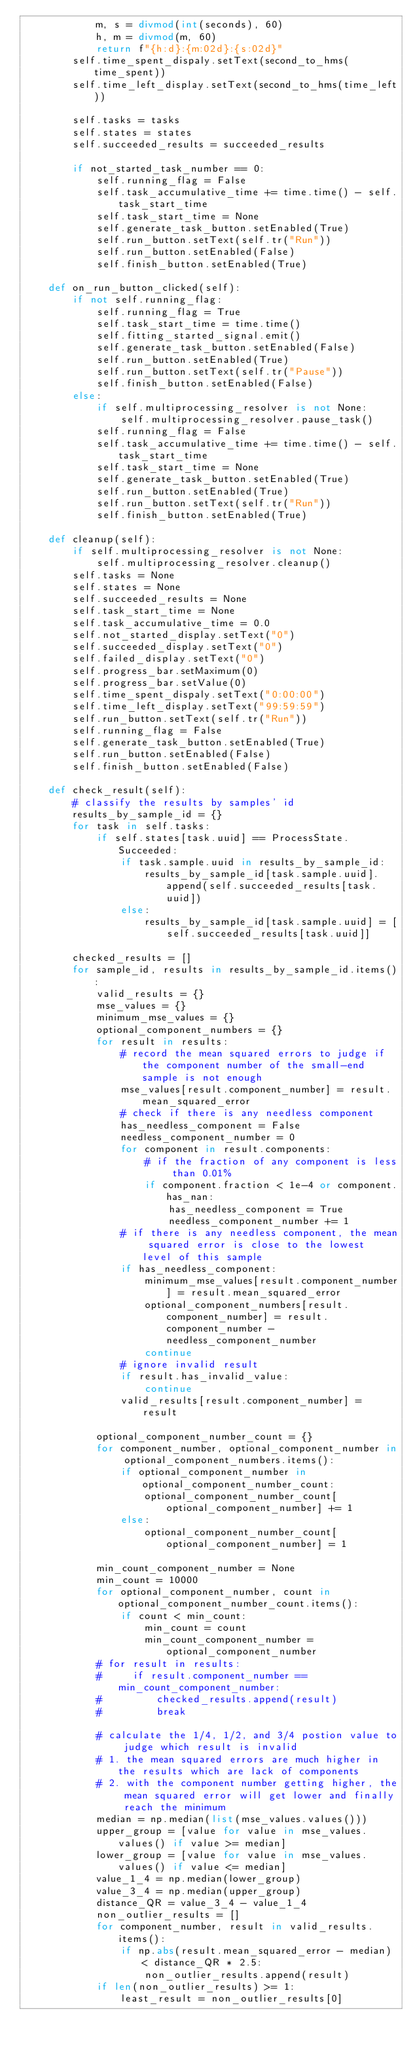Convert code to text. <code><loc_0><loc_0><loc_500><loc_500><_Python_>            m, s = divmod(int(seconds), 60)
            h, m = divmod(m, 60)
            return f"{h:d}:{m:02d}:{s:02d}"
        self.time_spent_dispaly.setText(second_to_hms(time_spent))
        self.time_left_display.setText(second_to_hms(time_left))

        self.tasks = tasks
        self.states = states
        self.succeeded_results = succeeded_results

        if not_started_task_number == 0:
            self.running_flag = False
            self.task_accumulative_time += time.time() - self.task_start_time
            self.task_start_time = None
            self.generate_task_button.setEnabled(True)
            self.run_button.setText(self.tr("Run"))
            self.run_button.setEnabled(False)
            self.finish_button.setEnabled(True)

    def on_run_button_clicked(self):
        if not self.running_flag:
            self.running_flag = True
            self.task_start_time = time.time()
            self.fitting_started_signal.emit()
            self.generate_task_button.setEnabled(False)
            self.run_button.setEnabled(True)
            self.run_button.setText(self.tr("Pause"))
            self.finish_button.setEnabled(False)
        else:
            if self.multiprocessing_resolver is not None:
                self.multiprocessing_resolver.pause_task()
            self.running_flag = False
            self.task_accumulative_time += time.time() - self.task_start_time
            self.task_start_time = None
            self.generate_task_button.setEnabled(True)
            self.run_button.setEnabled(True)
            self.run_button.setText(self.tr("Run"))
            self.finish_button.setEnabled(True)

    def cleanup(self):
        if self.multiprocessing_resolver is not None:
            self.multiprocessing_resolver.cleanup()
        self.tasks = None
        self.states = None
        self.succeeded_results = None
        self.task_start_time = None
        self.task_accumulative_time = 0.0
        self.not_started_display.setText("0")
        self.succeeded_display.setText("0")
        self.failed_display.setText("0")
        self.progress_bar.setMaximum(0)
        self.progress_bar.setValue(0)
        self.time_spent_dispaly.setText("0:00:00")
        self.time_left_display.setText("99:59:59")
        self.run_button.setText(self.tr("Run"))
        self.running_flag = False
        self.generate_task_button.setEnabled(True)
        self.run_button.setEnabled(False)
        self.finish_button.setEnabled(False)

    def check_result(self):
        # classify the results by samples' id
        results_by_sample_id = {}
        for task in self.tasks:
            if self.states[task.uuid] == ProcessState.Succeeded:
                if task.sample.uuid in results_by_sample_id:
                    results_by_sample_id[task.sample.uuid].append(self.succeeded_results[task.uuid])
                else:
                    results_by_sample_id[task.sample.uuid] = [self.succeeded_results[task.uuid]]

        checked_results = []
        for sample_id, results in results_by_sample_id.items():
            valid_results = {}
            mse_values = {}
            minimum_mse_values = {}
            optional_component_numbers = {}
            for result in results:
                # record the mean squared errors to judge if the component number of the small-end sample is not enough
                mse_values[result.component_number] = result.mean_squared_error
                # check if there is any needless component
                has_needless_component = False
                needless_component_number = 0
                for component in result.components:
                    # if the fraction of any component is less than 0.01%
                    if component.fraction < 1e-4 or component.has_nan:
                        has_needless_component = True
                        needless_component_number += 1
                # if there is any needless component, the mean squared error is close to the lowest level of this sample
                if has_needless_component:
                    minimum_mse_values[result.component_number] = result.mean_squared_error
                    optional_component_numbers[result.component_number] = result.component_number - needless_component_number
                    continue
                # ignore invalid result
                if result.has_invalid_value:
                    continue
                valid_results[result.component_number] = result

            optional_component_number_count = {}
            for component_number, optional_component_number in optional_component_numbers.items():
                if optional_component_number in optional_component_number_count:
                    optional_component_number_count[optional_component_number] += 1
                else:
                    optional_component_number_count[optional_component_number] = 1

            min_count_component_number = None
            min_count = 10000
            for optional_component_number, count in optional_component_number_count.items():
                if count < min_count:
                    min_count = count
                    min_count_component_number = optional_component_number
            # for result in results:
            #     if result.component_number == min_count_component_number:
            #         checked_results.append(result)
            #         break

            # calculate the 1/4, 1/2, and 3/4 postion value to judge which result is invalid
            # 1. the mean squared errors are much higher in the results which are lack of components
            # 2. with the component number getting higher, the mean squared error will get lower and finally reach the minimum
            median = np.median(list(mse_values.values()))
            upper_group = [value for value in mse_values.values() if value >= median]
            lower_group = [value for value in mse_values.values() if value <= median]
            value_1_4 = np.median(lower_group)
            value_3_4 = np.median(upper_group)
            distance_QR = value_3_4 - value_1_4
            non_outlier_results = []
            for component_number, result in valid_results.items():
                if np.abs(result.mean_squared_error - median) < distance_QR * 2.5:
                    non_outlier_results.append(result)
            if len(non_outlier_results) >= 1:
                least_result = non_outlier_results[0]</code> 